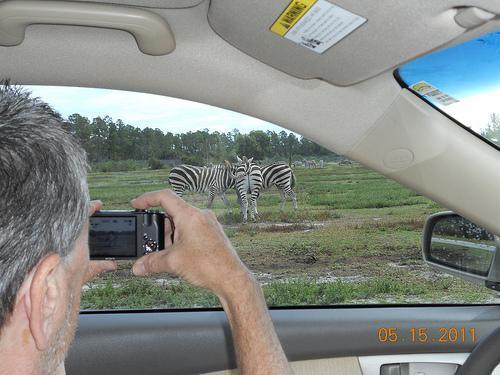How many people are in the photo?
Give a very brief answer. 1. 